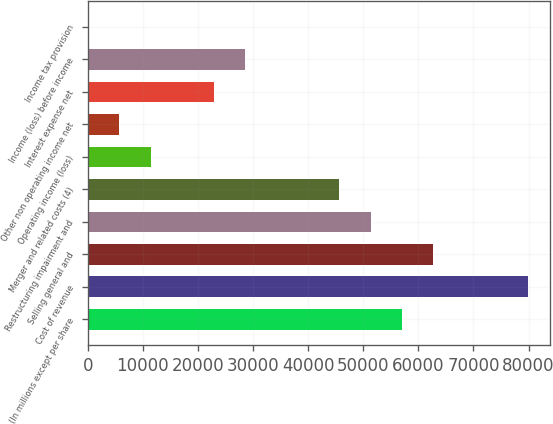Convert chart to OTSL. <chart><loc_0><loc_0><loc_500><loc_500><bar_chart><fcel>(In millions except per share<fcel>Cost of revenue<fcel>Selling general and<fcel>Restructuring impairment and<fcel>Merger and related costs (4)<fcel>Operating income (loss)<fcel>Other non operating income net<fcel>Interest expense net<fcel>Income (loss) before income<fcel>Income tax provision<nl><fcel>57050<fcel>79841.6<fcel>62747.9<fcel>51352.1<fcel>45654.2<fcel>11466.8<fcel>5768.9<fcel>22862.6<fcel>28560.5<fcel>71<nl></chart> 